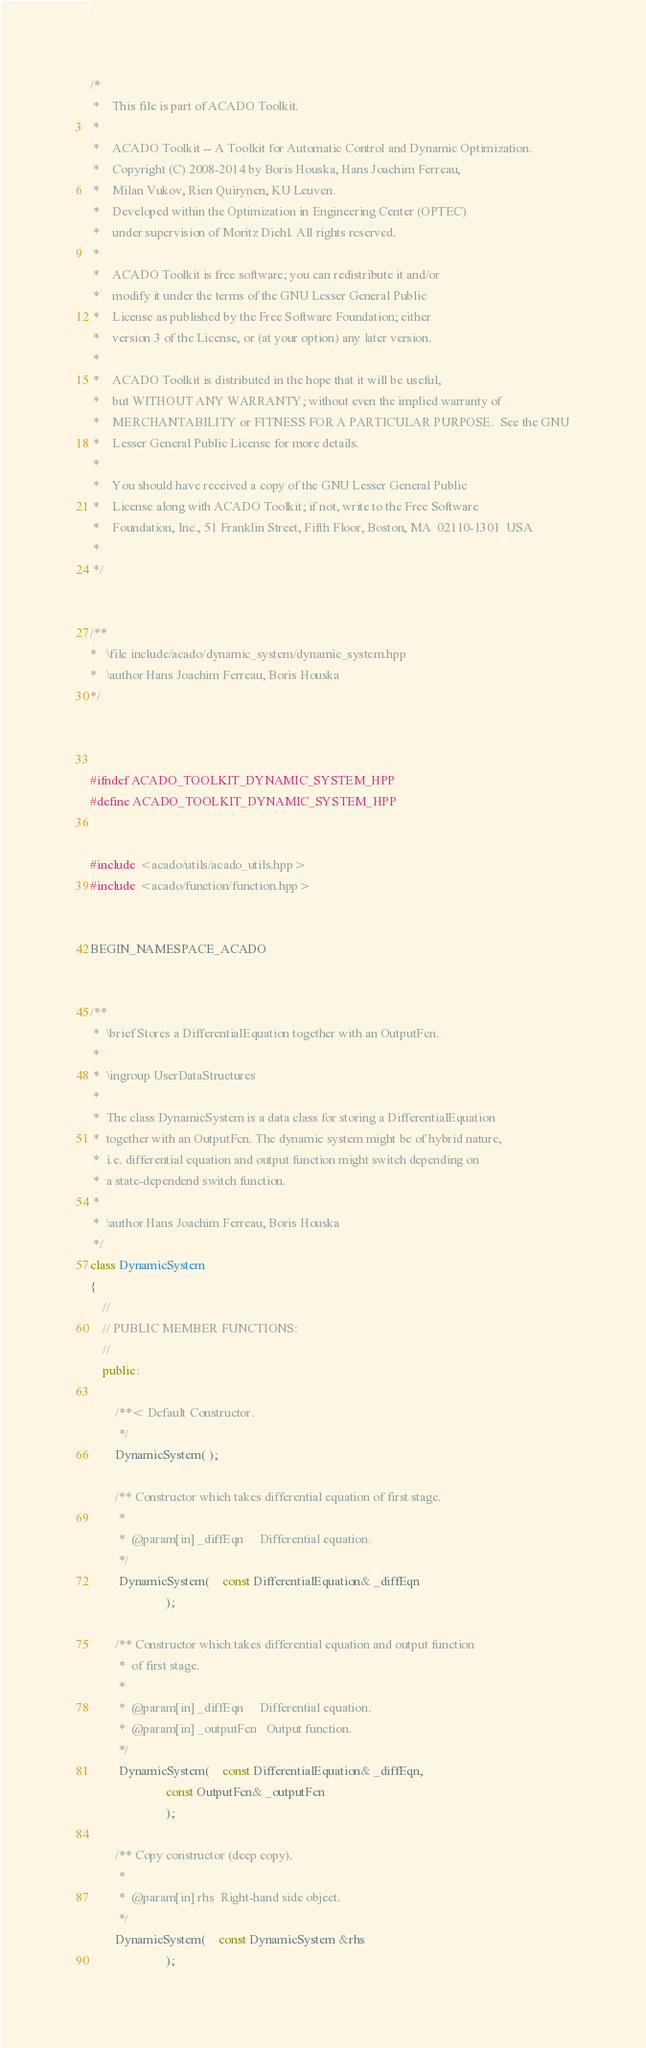<code> <loc_0><loc_0><loc_500><loc_500><_C++_>/*
 *    This file is part of ACADO Toolkit.
 *
 *    ACADO Toolkit -- A Toolkit for Automatic Control and Dynamic Optimization.
 *    Copyright (C) 2008-2014 by Boris Houska, Hans Joachim Ferreau,
 *    Milan Vukov, Rien Quirynen, KU Leuven.
 *    Developed within the Optimization in Engineering Center (OPTEC)
 *    under supervision of Moritz Diehl. All rights reserved.
 *
 *    ACADO Toolkit is free software; you can redistribute it and/or
 *    modify it under the terms of the GNU Lesser General Public
 *    License as published by the Free Software Foundation; either
 *    version 3 of the License, or (at your option) any later version.
 *
 *    ACADO Toolkit is distributed in the hope that it will be useful,
 *    but WITHOUT ANY WARRANTY; without even the implied warranty of
 *    MERCHANTABILITY or FITNESS FOR A PARTICULAR PURPOSE.  See the GNU
 *    Lesser General Public License for more details.
 *
 *    You should have received a copy of the GNU Lesser General Public
 *    License along with ACADO Toolkit; if not, write to the Free Software
 *    Foundation, Inc., 51 Franklin Street, Fifth Floor, Boston, MA  02110-1301  USA
 *
 */


/**
*	\file include/acado/dynamic_system/dynamic_system.hpp
*	\author Hans Joachim Ferreau, Boris Houska
*/



#ifndef ACADO_TOOLKIT_DYNAMIC_SYSTEM_HPP
#define ACADO_TOOLKIT_DYNAMIC_SYSTEM_HPP


#include <acado/utils/acado_utils.hpp>
#include <acado/function/function.hpp>


BEGIN_NAMESPACE_ACADO


/** 
 *	\brief Stores a DifferentialEquation together with an OutputFcn.
 *
 *	\ingroup UserDataStructures
 *
 *  The class DynamicSystem is a data class for storing a DifferentialEquation
 *	together with an OutputFcn. The dynamic system might be of hybrid nature,
 *	i.e. differential equation and output function might switch depending on
 *	a state-dependend switch function.
 *
 *	\author Hans Joachim Ferreau, Boris Houska
 */
class DynamicSystem
{
	//
	// PUBLIC MEMBER FUNCTIONS:
	//
	public:

		/**< Default Constructor. 
		 */
		DynamicSystem( );

		/** Constructor which takes differential equation of first stage.
		 *
		 *	@param[in] _diffEqn		Differential equation.
		 */
		 DynamicSystem(	const DifferentialEquation& _diffEqn
						);

		/** Constructor which takes differential equation and output function 
		 *	of first stage.
		 *
		 *	@param[in] _diffEqn		Differential equation.
		 *	@param[in] _outputFcn	Output function.
		 */
		 DynamicSystem(	const DifferentialEquation& _diffEqn,
						const OutputFcn& _outputFcn
						);

		/** Copy constructor (deep copy).
		 *
		 *	@param[in] rhs	Right-hand side object.
		 */
		DynamicSystem(	const DynamicSystem &rhs
						);
</code> 